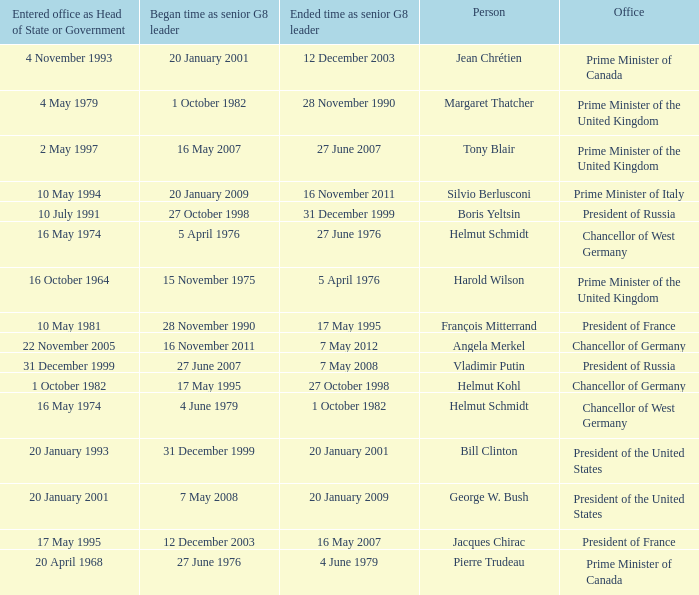When did Jacques Chirac stop being a G8 leader? 16 May 2007. 